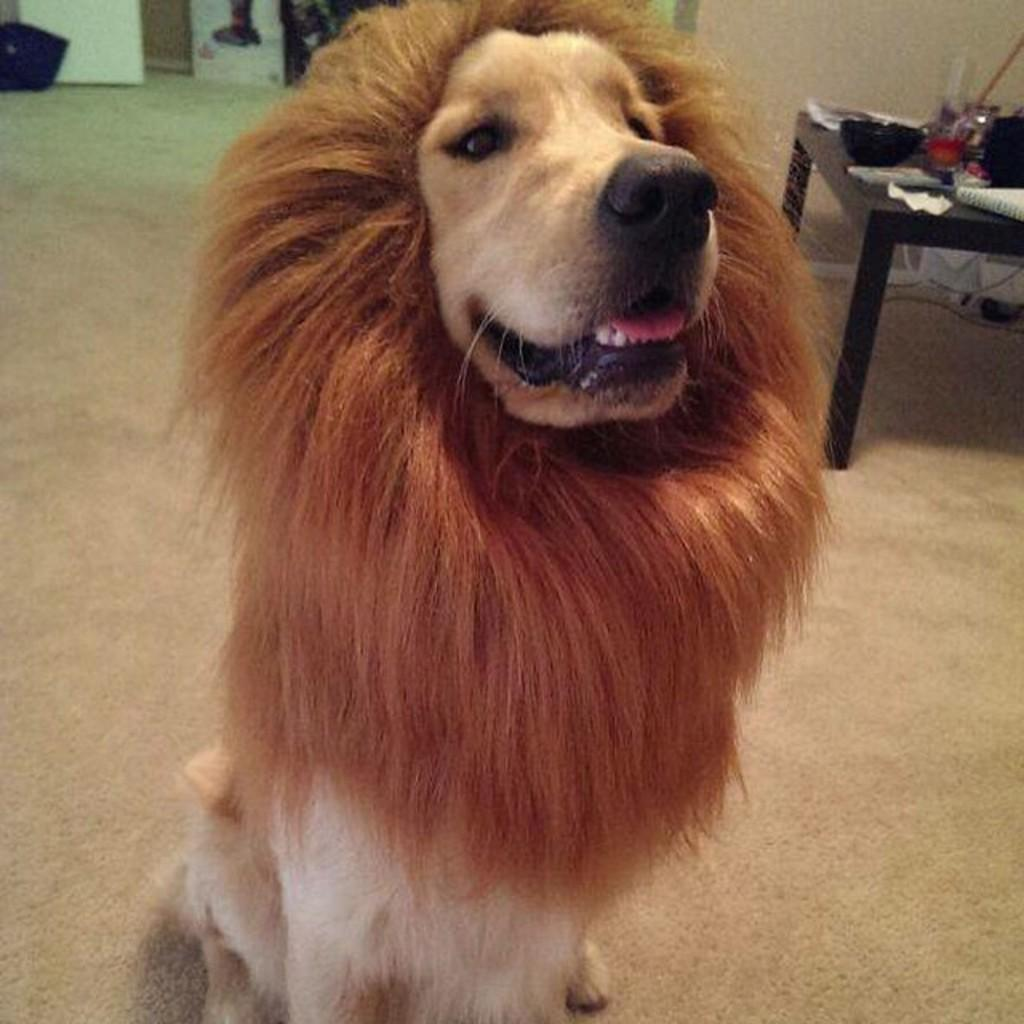What type of animal is in the image? A: There is a dog in the image. What is the dog wearing? The dog is wearing a lion's mask. Where is the dog located in the image? The dog is standing on the floor. What can be seen in the background of the image? There is a table in the background of the image, and there are items placed on the table. What time of day is it in the image, and how many cherries are on the table? The provided facts do not mention the time of day or the presence of cherries in the image. 